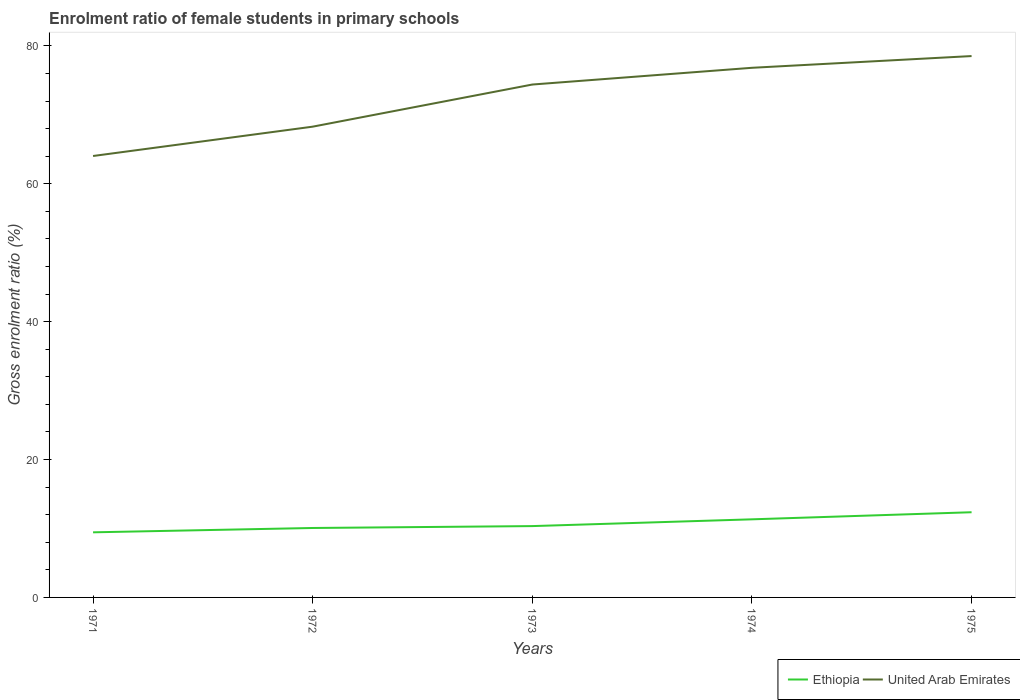How many different coloured lines are there?
Provide a succinct answer. 2. Across all years, what is the maximum enrolment ratio of female students in primary schools in Ethiopia?
Provide a short and direct response. 9.44. What is the total enrolment ratio of female students in primary schools in Ethiopia in the graph?
Give a very brief answer. -2.91. What is the difference between the highest and the second highest enrolment ratio of female students in primary schools in Ethiopia?
Your response must be concise. 2.91. Is the enrolment ratio of female students in primary schools in Ethiopia strictly greater than the enrolment ratio of female students in primary schools in United Arab Emirates over the years?
Give a very brief answer. Yes. How many years are there in the graph?
Keep it short and to the point. 5. Are the values on the major ticks of Y-axis written in scientific E-notation?
Provide a succinct answer. No. Does the graph contain any zero values?
Keep it short and to the point. No. Where does the legend appear in the graph?
Offer a very short reply. Bottom right. How many legend labels are there?
Keep it short and to the point. 2. How are the legend labels stacked?
Provide a short and direct response. Horizontal. What is the title of the graph?
Ensure brevity in your answer.  Enrolment ratio of female students in primary schools. What is the Gross enrolment ratio (%) in Ethiopia in 1971?
Make the answer very short. 9.44. What is the Gross enrolment ratio (%) of United Arab Emirates in 1971?
Your answer should be very brief. 64.03. What is the Gross enrolment ratio (%) of Ethiopia in 1972?
Your answer should be very brief. 10.07. What is the Gross enrolment ratio (%) in United Arab Emirates in 1972?
Your response must be concise. 68.29. What is the Gross enrolment ratio (%) in Ethiopia in 1973?
Give a very brief answer. 10.35. What is the Gross enrolment ratio (%) in United Arab Emirates in 1973?
Keep it short and to the point. 74.4. What is the Gross enrolment ratio (%) in Ethiopia in 1974?
Offer a terse response. 11.33. What is the Gross enrolment ratio (%) of United Arab Emirates in 1974?
Keep it short and to the point. 76.83. What is the Gross enrolment ratio (%) in Ethiopia in 1975?
Make the answer very short. 12.36. What is the Gross enrolment ratio (%) in United Arab Emirates in 1975?
Your answer should be compact. 78.53. Across all years, what is the maximum Gross enrolment ratio (%) of Ethiopia?
Ensure brevity in your answer.  12.36. Across all years, what is the maximum Gross enrolment ratio (%) in United Arab Emirates?
Make the answer very short. 78.53. Across all years, what is the minimum Gross enrolment ratio (%) in Ethiopia?
Offer a terse response. 9.44. Across all years, what is the minimum Gross enrolment ratio (%) in United Arab Emirates?
Your answer should be compact. 64.03. What is the total Gross enrolment ratio (%) in Ethiopia in the graph?
Keep it short and to the point. 53.55. What is the total Gross enrolment ratio (%) of United Arab Emirates in the graph?
Offer a terse response. 362.07. What is the difference between the Gross enrolment ratio (%) in Ethiopia in 1971 and that in 1972?
Provide a succinct answer. -0.63. What is the difference between the Gross enrolment ratio (%) in United Arab Emirates in 1971 and that in 1972?
Your answer should be compact. -4.25. What is the difference between the Gross enrolment ratio (%) in Ethiopia in 1971 and that in 1973?
Ensure brevity in your answer.  -0.9. What is the difference between the Gross enrolment ratio (%) of United Arab Emirates in 1971 and that in 1973?
Offer a very short reply. -10.37. What is the difference between the Gross enrolment ratio (%) in Ethiopia in 1971 and that in 1974?
Provide a short and direct response. -1.88. What is the difference between the Gross enrolment ratio (%) in United Arab Emirates in 1971 and that in 1974?
Ensure brevity in your answer.  -12.79. What is the difference between the Gross enrolment ratio (%) of Ethiopia in 1971 and that in 1975?
Your response must be concise. -2.91. What is the difference between the Gross enrolment ratio (%) in United Arab Emirates in 1971 and that in 1975?
Provide a succinct answer. -14.49. What is the difference between the Gross enrolment ratio (%) in Ethiopia in 1972 and that in 1973?
Provide a short and direct response. -0.27. What is the difference between the Gross enrolment ratio (%) of United Arab Emirates in 1972 and that in 1973?
Ensure brevity in your answer.  -6.11. What is the difference between the Gross enrolment ratio (%) of Ethiopia in 1972 and that in 1974?
Offer a very short reply. -1.26. What is the difference between the Gross enrolment ratio (%) of United Arab Emirates in 1972 and that in 1974?
Ensure brevity in your answer.  -8.54. What is the difference between the Gross enrolment ratio (%) of Ethiopia in 1972 and that in 1975?
Keep it short and to the point. -2.29. What is the difference between the Gross enrolment ratio (%) in United Arab Emirates in 1972 and that in 1975?
Offer a terse response. -10.24. What is the difference between the Gross enrolment ratio (%) of Ethiopia in 1973 and that in 1974?
Provide a succinct answer. -0.98. What is the difference between the Gross enrolment ratio (%) of United Arab Emirates in 1973 and that in 1974?
Your answer should be compact. -2.43. What is the difference between the Gross enrolment ratio (%) in Ethiopia in 1973 and that in 1975?
Provide a short and direct response. -2.01. What is the difference between the Gross enrolment ratio (%) in United Arab Emirates in 1973 and that in 1975?
Your response must be concise. -4.13. What is the difference between the Gross enrolment ratio (%) in Ethiopia in 1974 and that in 1975?
Your response must be concise. -1.03. What is the difference between the Gross enrolment ratio (%) in United Arab Emirates in 1974 and that in 1975?
Keep it short and to the point. -1.7. What is the difference between the Gross enrolment ratio (%) in Ethiopia in 1971 and the Gross enrolment ratio (%) in United Arab Emirates in 1972?
Your response must be concise. -58.84. What is the difference between the Gross enrolment ratio (%) in Ethiopia in 1971 and the Gross enrolment ratio (%) in United Arab Emirates in 1973?
Ensure brevity in your answer.  -64.95. What is the difference between the Gross enrolment ratio (%) of Ethiopia in 1971 and the Gross enrolment ratio (%) of United Arab Emirates in 1974?
Offer a very short reply. -67.38. What is the difference between the Gross enrolment ratio (%) in Ethiopia in 1971 and the Gross enrolment ratio (%) in United Arab Emirates in 1975?
Provide a succinct answer. -69.08. What is the difference between the Gross enrolment ratio (%) of Ethiopia in 1972 and the Gross enrolment ratio (%) of United Arab Emirates in 1973?
Your response must be concise. -64.33. What is the difference between the Gross enrolment ratio (%) in Ethiopia in 1972 and the Gross enrolment ratio (%) in United Arab Emirates in 1974?
Keep it short and to the point. -66.75. What is the difference between the Gross enrolment ratio (%) in Ethiopia in 1972 and the Gross enrolment ratio (%) in United Arab Emirates in 1975?
Provide a short and direct response. -68.46. What is the difference between the Gross enrolment ratio (%) in Ethiopia in 1973 and the Gross enrolment ratio (%) in United Arab Emirates in 1974?
Ensure brevity in your answer.  -66.48. What is the difference between the Gross enrolment ratio (%) of Ethiopia in 1973 and the Gross enrolment ratio (%) of United Arab Emirates in 1975?
Ensure brevity in your answer.  -68.18. What is the difference between the Gross enrolment ratio (%) in Ethiopia in 1974 and the Gross enrolment ratio (%) in United Arab Emirates in 1975?
Give a very brief answer. -67.2. What is the average Gross enrolment ratio (%) in Ethiopia per year?
Keep it short and to the point. 10.71. What is the average Gross enrolment ratio (%) of United Arab Emirates per year?
Keep it short and to the point. 72.41. In the year 1971, what is the difference between the Gross enrolment ratio (%) of Ethiopia and Gross enrolment ratio (%) of United Arab Emirates?
Offer a terse response. -54.59. In the year 1972, what is the difference between the Gross enrolment ratio (%) in Ethiopia and Gross enrolment ratio (%) in United Arab Emirates?
Your answer should be compact. -58.22. In the year 1973, what is the difference between the Gross enrolment ratio (%) in Ethiopia and Gross enrolment ratio (%) in United Arab Emirates?
Ensure brevity in your answer.  -64.05. In the year 1974, what is the difference between the Gross enrolment ratio (%) in Ethiopia and Gross enrolment ratio (%) in United Arab Emirates?
Make the answer very short. -65.5. In the year 1975, what is the difference between the Gross enrolment ratio (%) in Ethiopia and Gross enrolment ratio (%) in United Arab Emirates?
Your response must be concise. -66.17. What is the ratio of the Gross enrolment ratio (%) in Ethiopia in 1971 to that in 1972?
Make the answer very short. 0.94. What is the ratio of the Gross enrolment ratio (%) in United Arab Emirates in 1971 to that in 1972?
Provide a short and direct response. 0.94. What is the ratio of the Gross enrolment ratio (%) in Ethiopia in 1971 to that in 1973?
Your response must be concise. 0.91. What is the ratio of the Gross enrolment ratio (%) in United Arab Emirates in 1971 to that in 1973?
Keep it short and to the point. 0.86. What is the ratio of the Gross enrolment ratio (%) in Ethiopia in 1971 to that in 1974?
Offer a terse response. 0.83. What is the ratio of the Gross enrolment ratio (%) in United Arab Emirates in 1971 to that in 1974?
Provide a short and direct response. 0.83. What is the ratio of the Gross enrolment ratio (%) of Ethiopia in 1971 to that in 1975?
Ensure brevity in your answer.  0.76. What is the ratio of the Gross enrolment ratio (%) in United Arab Emirates in 1971 to that in 1975?
Ensure brevity in your answer.  0.82. What is the ratio of the Gross enrolment ratio (%) of Ethiopia in 1972 to that in 1973?
Give a very brief answer. 0.97. What is the ratio of the Gross enrolment ratio (%) of United Arab Emirates in 1972 to that in 1973?
Keep it short and to the point. 0.92. What is the ratio of the Gross enrolment ratio (%) of Ethiopia in 1972 to that in 1974?
Your response must be concise. 0.89. What is the ratio of the Gross enrolment ratio (%) in Ethiopia in 1972 to that in 1975?
Keep it short and to the point. 0.81. What is the ratio of the Gross enrolment ratio (%) of United Arab Emirates in 1972 to that in 1975?
Your answer should be compact. 0.87. What is the ratio of the Gross enrolment ratio (%) of Ethiopia in 1973 to that in 1974?
Offer a terse response. 0.91. What is the ratio of the Gross enrolment ratio (%) of United Arab Emirates in 1973 to that in 1974?
Make the answer very short. 0.97. What is the ratio of the Gross enrolment ratio (%) of Ethiopia in 1973 to that in 1975?
Your answer should be very brief. 0.84. What is the ratio of the Gross enrolment ratio (%) in Ethiopia in 1974 to that in 1975?
Give a very brief answer. 0.92. What is the ratio of the Gross enrolment ratio (%) in United Arab Emirates in 1974 to that in 1975?
Your response must be concise. 0.98. What is the difference between the highest and the second highest Gross enrolment ratio (%) of Ethiopia?
Provide a succinct answer. 1.03. What is the difference between the highest and the second highest Gross enrolment ratio (%) in United Arab Emirates?
Offer a terse response. 1.7. What is the difference between the highest and the lowest Gross enrolment ratio (%) in Ethiopia?
Your response must be concise. 2.91. What is the difference between the highest and the lowest Gross enrolment ratio (%) of United Arab Emirates?
Provide a succinct answer. 14.49. 